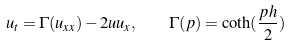<formula> <loc_0><loc_0><loc_500><loc_500>u _ { t } = \Gamma ( u _ { x x } ) - 2 u u _ { x } , \quad \Gamma ( p ) = \coth ( \frac { p h } { 2 } )</formula> 